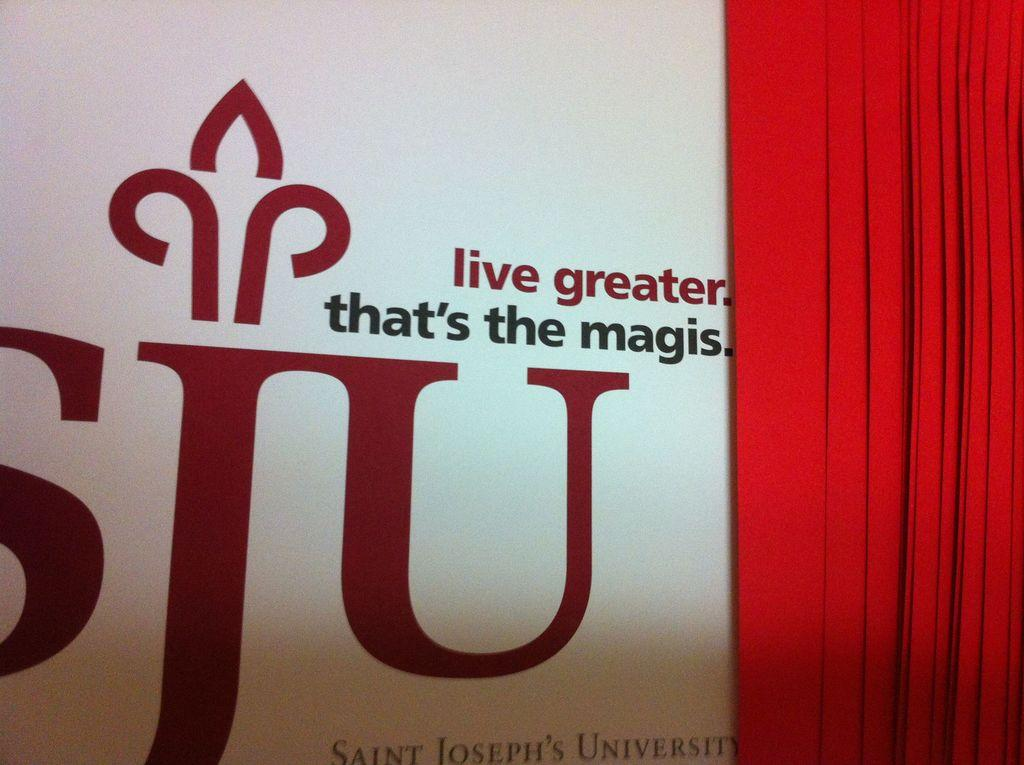<image>
Present a compact description of the photo's key features. Wall with a red curtain and red words that say "Live Greater". 